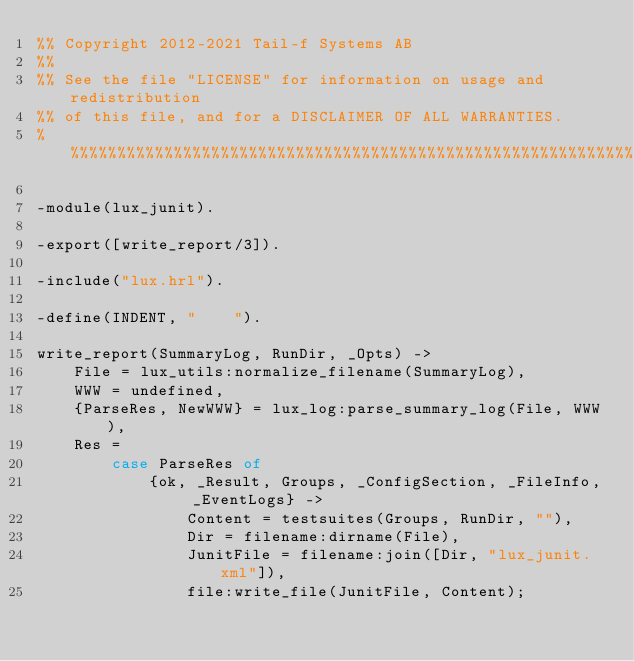Convert code to text. <code><loc_0><loc_0><loc_500><loc_500><_Erlang_>%% Copyright 2012-2021 Tail-f Systems AB
%%
%% See the file "LICENSE" for information on usage and redistribution
%% of this file, and for a DISCLAIMER OF ALL WARRANTIES.
%%%%%%%%%%%%%%%%%%%%%%%%%%%%%%%%%%%%%%%%%%%%%%%%%%%%%%%%%%%%%%%%%%%%%%

-module(lux_junit).

-export([write_report/3]).

-include("lux.hrl").

-define(INDENT, "    ").

write_report(SummaryLog, RunDir, _Opts) ->
    File = lux_utils:normalize_filename(SummaryLog),
    WWW = undefined,
    {ParseRes, NewWWW} = lux_log:parse_summary_log(File, WWW),
    Res =
        case ParseRes of
            {ok, _Result, Groups, _ConfigSection, _FileInfo, _EventLogs} ->
                Content = testsuites(Groups, RunDir, ""),
                Dir = filename:dirname(File),
                JunitFile = filename:join([Dir, "lux_junit.xml"]),
                file:write_file(JunitFile, Content);</code> 